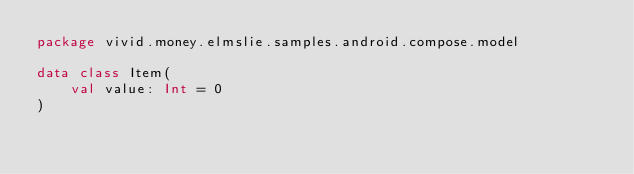Convert code to text. <code><loc_0><loc_0><loc_500><loc_500><_Kotlin_>package vivid.money.elmslie.samples.android.compose.model

data class Item(
    val value: Int = 0
)
</code> 